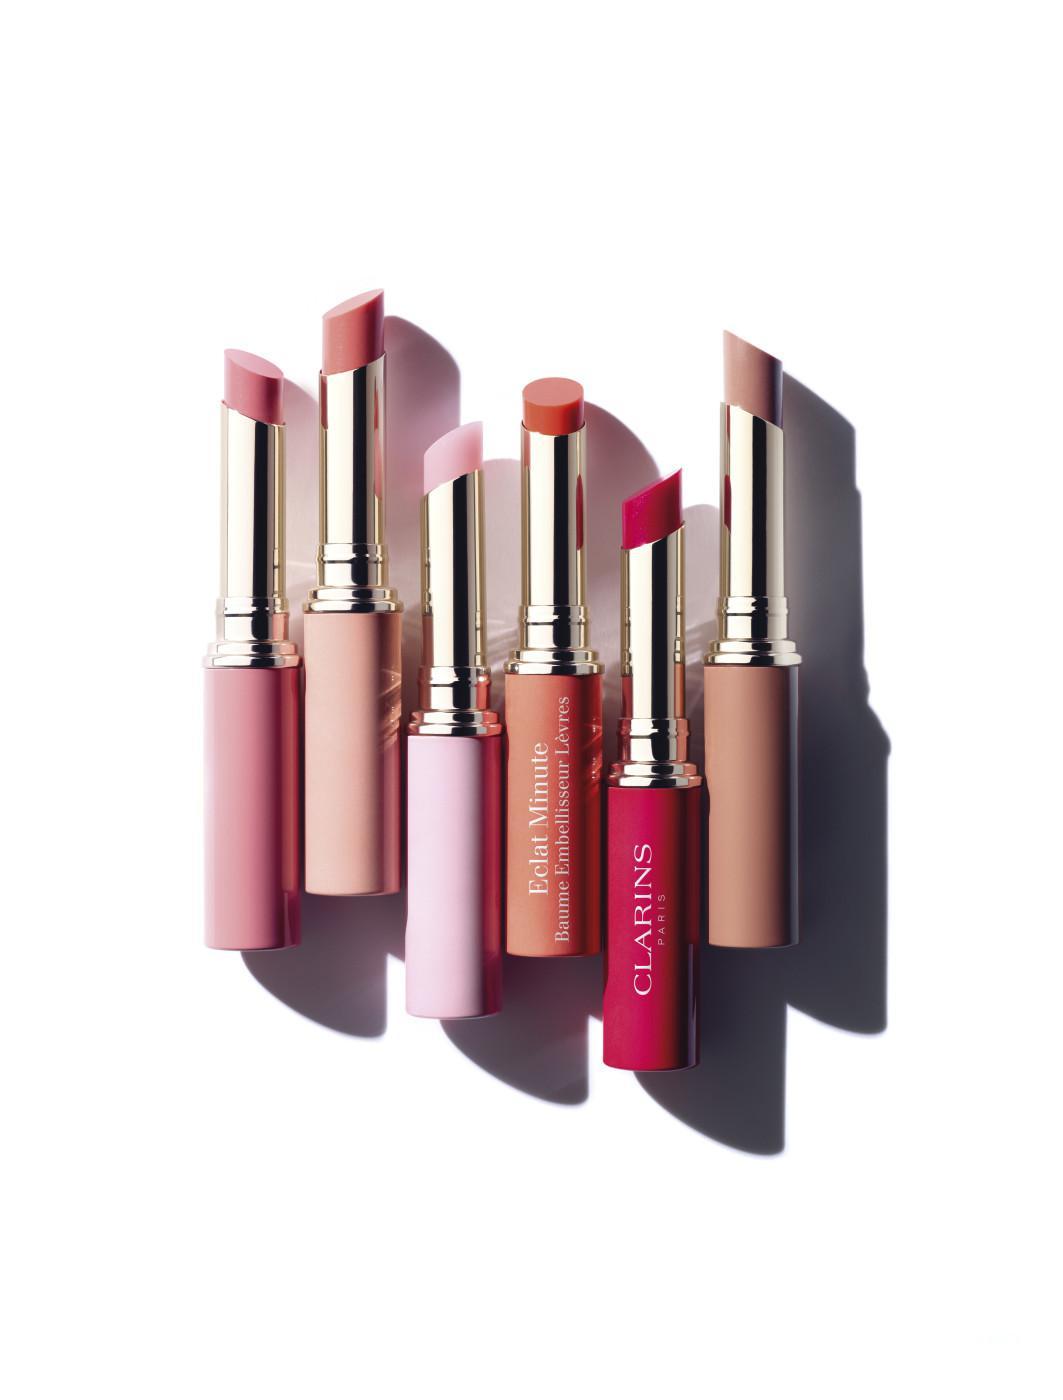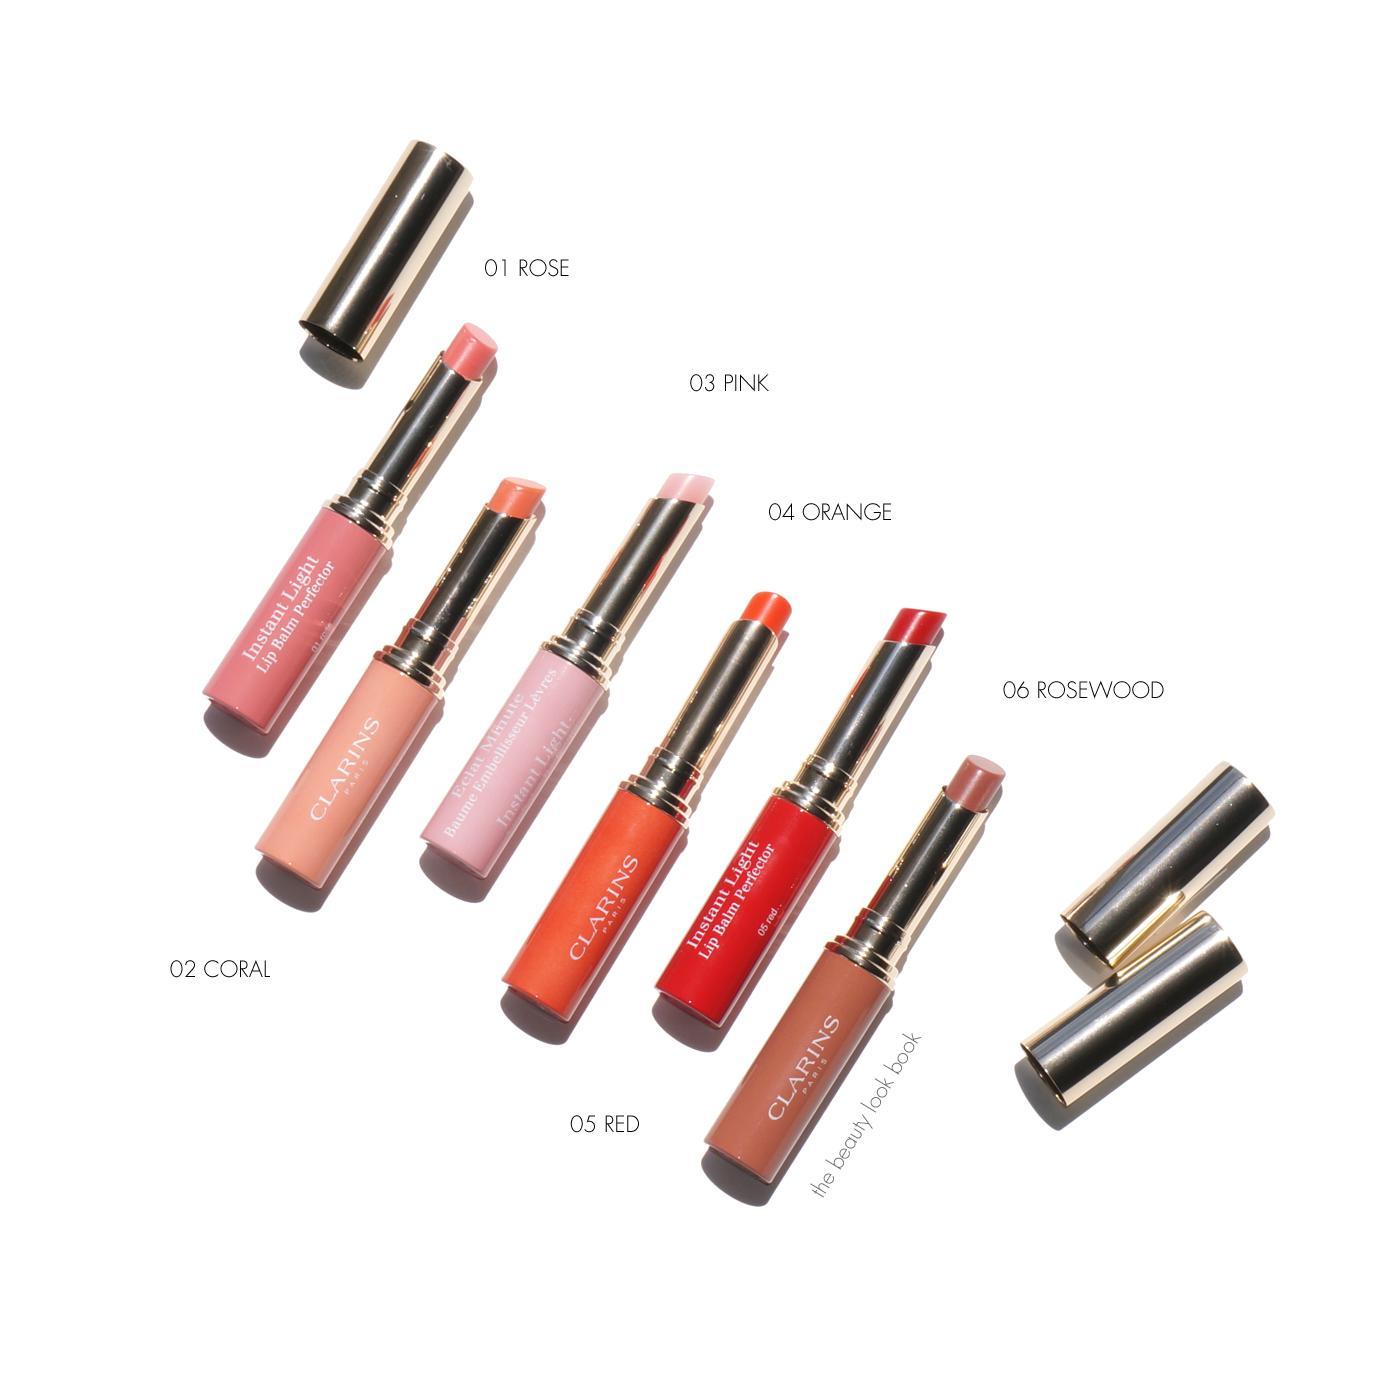The first image is the image on the left, the second image is the image on the right. Considering the images on both sides, is "Someone is holding some lip stick." valid? Answer yes or no. No. The first image is the image on the left, the second image is the image on the right. Analyze the images presented: Is the assertion "Many shades of reddish lipstick are shown with the caps off in at least one of the pictures." valid? Answer yes or no. Yes. 